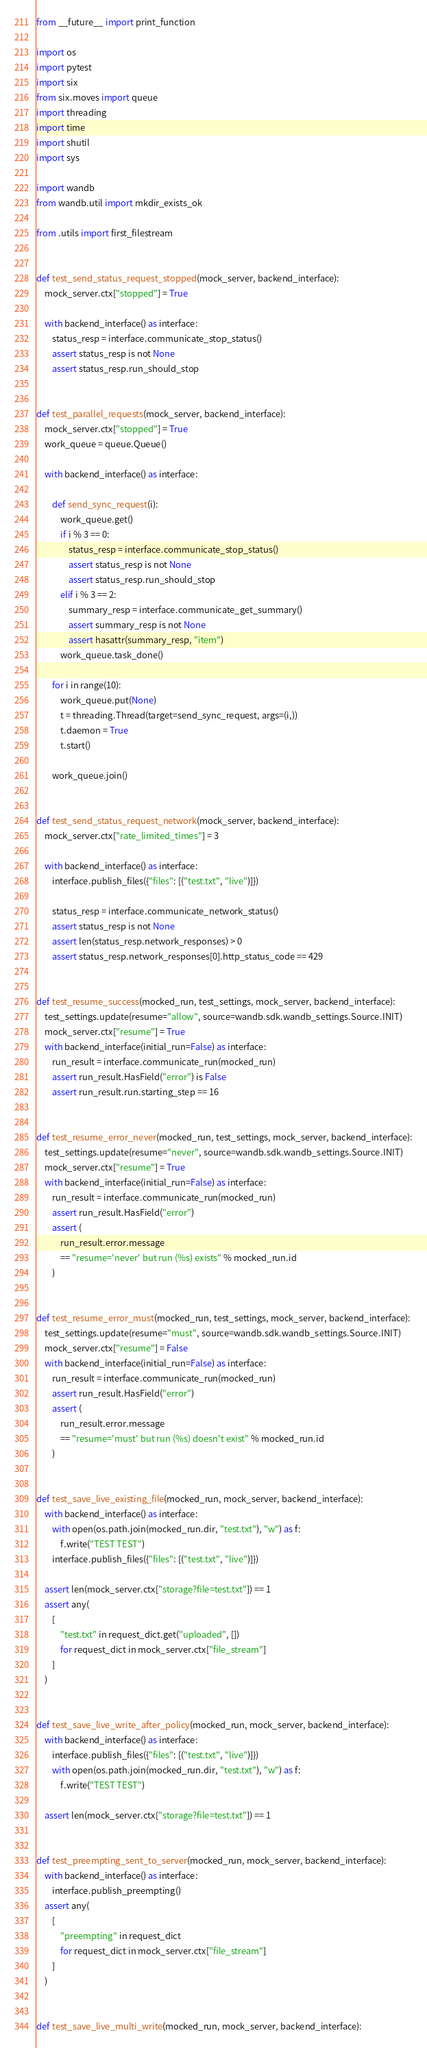<code> <loc_0><loc_0><loc_500><loc_500><_Python_>from __future__ import print_function

import os
import pytest
import six
from six.moves import queue
import threading
import time
import shutil
import sys

import wandb
from wandb.util import mkdir_exists_ok

from .utils import first_filestream


def test_send_status_request_stopped(mock_server, backend_interface):
    mock_server.ctx["stopped"] = True

    with backend_interface() as interface:
        status_resp = interface.communicate_stop_status()
        assert status_resp is not None
        assert status_resp.run_should_stop


def test_parallel_requests(mock_server, backend_interface):
    mock_server.ctx["stopped"] = True
    work_queue = queue.Queue()

    with backend_interface() as interface:

        def send_sync_request(i):
            work_queue.get()
            if i % 3 == 0:
                status_resp = interface.communicate_stop_status()
                assert status_resp is not None
                assert status_resp.run_should_stop
            elif i % 3 == 2:
                summary_resp = interface.communicate_get_summary()
                assert summary_resp is not None
                assert hasattr(summary_resp, "item")
            work_queue.task_done()

        for i in range(10):
            work_queue.put(None)
            t = threading.Thread(target=send_sync_request, args=(i,))
            t.daemon = True
            t.start()

        work_queue.join()


def test_send_status_request_network(mock_server, backend_interface):
    mock_server.ctx["rate_limited_times"] = 3

    with backend_interface() as interface:
        interface.publish_files({"files": [("test.txt", "live")]})

        status_resp = interface.communicate_network_status()
        assert status_resp is not None
        assert len(status_resp.network_responses) > 0
        assert status_resp.network_responses[0].http_status_code == 429


def test_resume_success(mocked_run, test_settings, mock_server, backend_interface):
    test_settings.update(resume="allow", source=wandb.sdk.wandb_settings.Source.INIT)
    mock_server.ctx["resume"] = True
    with backend_interface(initial_run=False) as interface:
        run_result = interface.communicate_run(mocked_run)
        assert run_result.HasField("error") is False
        assert run_result.run.starting_step == 16


def test_resume_error_never(mocked_run, test_settings, mock_server, backend_interface):
    test_settings.update(resume="never", source=wandb.sdk.wandb_settings.Source.INIT)
    mock_server.ctx["resume"] = True
    with backend_interface(initial_run=False) as interface:
        run_result = interface.communicate_run(mocked_run)
        assert run_result.HasField("error")
        assert (
            run_result.error.message
            == "resume='never' but run (%s) exists" % mocked_run.id
        )


def test_resume_error_must(mocked_run, test_settings, mock_server, backend_interface):
    test_settings.update(resume="must", source=wandb.sdk.wandb_settings.Source.INIT)
    mock_server.ctx["resume"] = False
    with backend_interface(initial_run=False) as interface:
        run_result = interface.communicate_run(mocked_run)
        assert run_result.HasField("error")
        assert (
            run_result.error.message
            == "resume='must' but run (%s) doesn't exist" % mocked_run.id
        )


def test_save_live_existing_file(mocked_run, mock_server, backend_interface):
    with backend_interface() as interface:
        with open(os.path.join(mocked_run.dir, "test.txt"), "w") as f:
            f.write("TEST TEST")
        interface.publish_files({"files": [("test.txt", "live")]})

    assert len(mock_server.ctx["storage?file=test.txt"]) == 1
    assert any(
        [
            "test.txt" in request_dict.get("uploaded", [])
            for request_dict in mock_server.ctx["file_stream"]
        ]
    )


def test_save_live_write_after_policy(mocked_run, mock_server, backend_interface):
    with backend_interface() as interface:
        interface.publish_files({"files": [("test.txt", "live")]})
        with open(os.path.join(mocked_run.dir, "test.txt"), "w") as f:
            f.write("TEST TEST")

    assert len(mock_server.ctx["storage?file=test.txt"]) == 1


def test_preempting_sent_to_server(mocked_run, mock_server, backend_interface):
    with backend_interface() as interface:
        interface.publish_preempting()
    assert any(
        [
            "preempting" in request_dict
            for request_dict in mock_server.ctx["file_stream"]
        ]
    )


def test_save_live_multi_write(mocked_run, mock_server, backend_interface):</code> 